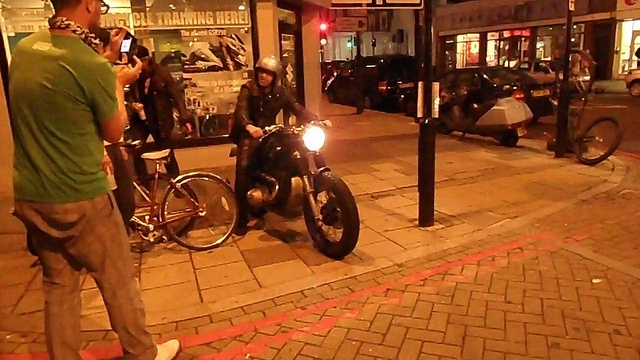Describe the objects in this image and their specific colors. I can see people in olive, brown, maroon, and black tones, motorcycle in olive, black, maroon, brown, and white tones, bicycle in olive, maroon, and brown tones, people in olive, black, maroon, brown, and orange tones, and people in olive, black, maroon, and brown tones in this image. 